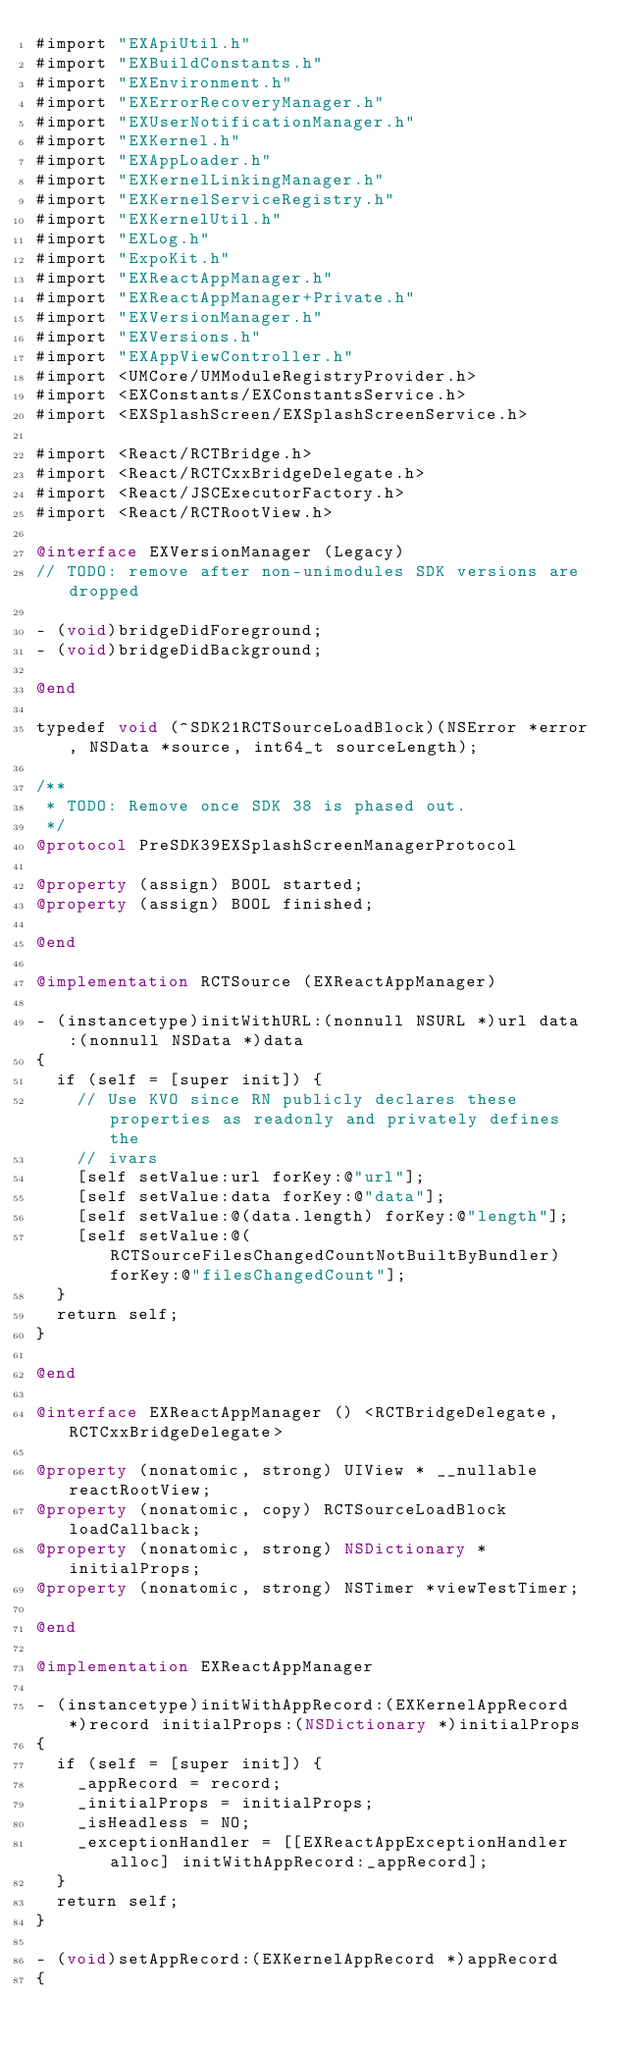<code> <loc_0><loc_0><loc_500><loc_500><_ObjectiveC_>#import "EXApiUtil.h"
#import "EXBuildConstants.h"
#import "EXEnvironment.h"
#import "EXErrorRecoveryManager.h"
#import "EXUserNotificationManager.h"
#import "EXKernel.h"
#import "EXAppLoader.h"
#import "EXKernelLinkingManager.h"
#import "EXKernelServiceRegistry.h"
#import "EXKernelUtil.h"
#import "EXLog.h"
#import "ExpoKit.h"
#import "EXReactAppManager.h"
#import "EXReactAppManager+Private.h"
#import "EXVersionManager.h"
#import "EXVersions.h"
#import "EXAppViewController.h"
#import <UMCore/UMModuleRegistryProvider.h>
#import <EXConstants/EXConstantsService.h>
#import <EXSplashScreen/EXSplashScreenService.h>

#import <React/RCTBridge.h>
#import <React/RCTCxxBridgeDelegate.h>
#import <React/JSCExecutorFactory.h>
#import <React/RCTRootView.h>

@interface EXVersionManager (Legacy)
// TODO: remove after non-unimodules SDK versions are dropped

- (void)bridgeDidForeground;
- (void)bridgeDidBackground;

@end

typedef void (^SDK21RCTSourceLoadBlock)(NSError *error, NSData *source, int64_t sourceLength);

/**
 * TODO: Remove once SDK 38 is phased out.
 */
@protocol PreSDK39EXSplashScreenManagerProtocol

@property (assign) BOOL started;
@property (assign) BOOL finished;

@end

@implementation RCTSource (EXReactAppManager)

- (instancetype)initWithURL:(nonnull NSURL *)url data:(nonnull NSData *)data
{
  if (self = [super init]) {
    // Use KVO since RN publicly declares these properties as readonly and privately defines the
    // ivars
    [self setValue:url forKey:@"url"];
    [self setValue:data forKey:@"data"];
    [self setValue:@(data.length) forKey:@"length"];
    [self setValue:@(RCTSourceFilesChangedCountNotBuiltByBundler) forKey:@"filesChangedCount"];
  }
  return self;
}

@end

@interface EXReactAppManager () <RCTBridgeDelegate, RCTCxxBridgeDelegate>

@property (nonatomic, strong) UIView * __nullable reactRootView;
@property (nonatomic, copy) RCTSourceLoadBlock loadCallback;
@property (nonatomic, strong) NSDictionary *initialProps;
@property (nonatomic, strong) NSTimer *viewTestTimer;

@end

@implementation EXReactAppManager

- (instancetype)initWithAppRecord:(EXKernelAppRecord *)record initialProps:(NSDictionary *)initialProps
{
  if (self = [super init]) {
    _appRecord = record;
    _initialProps = initialProps;
    _isHeadless = NO;
    _exceptionHandler = [[EXReactAppExceptionHandler alloc] initWithAppRecord:_appRecord];
  }
  return self;
}

- (void)setAppRecord:(EXKernelAppRecord *)appRecord
{</code> 